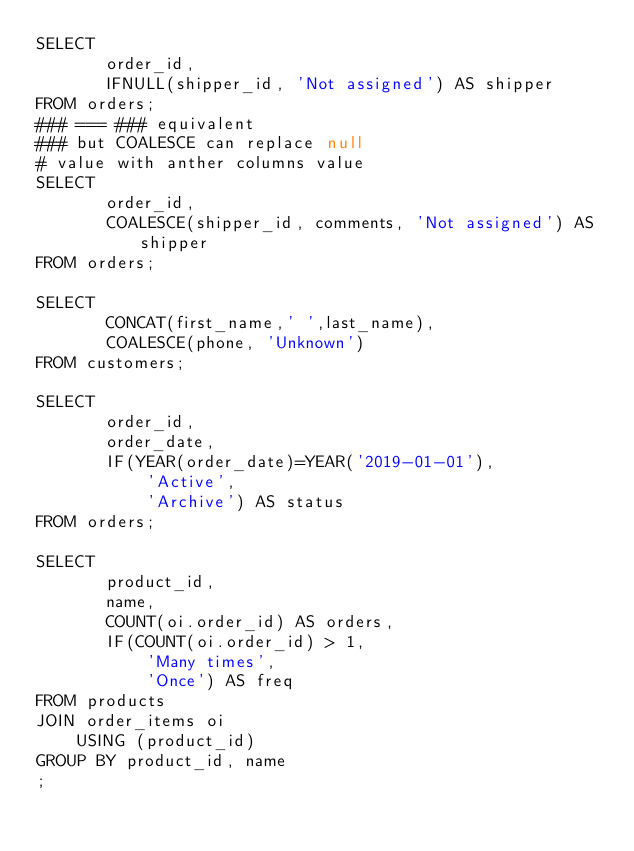Convert code to text. <code><loc_0><loc_0><loc_500><loc_500><_SQL_>SELECT
       order_id,
       IFNULL(shipper_id, 'Not assigned') AS shipper
FROM orders;
### === ### equivalent
### but COALESCE can replace null
# value with anther columns value
SELECT
       order_id,
       COALESCE(shipper_id, comments, 'Not assigned') AS shipper
FROM orders;

SELECT
       CONCAT(first_name,' ',last_name),
       COALESCE(phone, 'Unknown')
FROM customers;

SELECT
       order_id,
       order_date,
       IF(YEAR(order_date)=YEAR('2019-01-01'),
           'Active',
           'Archive') AS status
FROM orders;

SELECT
       product_id,
       name,
       COUNT(oi.order_id) AS orders,
       IF(COUNT(oi.order_id) > 1,
           'Many times',
           'Once') AS freq
FROM products
JOIN order_items oi
    USING (product_id)
GROUP BY product_id, name
;</code> 